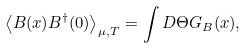Convert formula to latex. <formula><loc_0><loc_0><loc_500><loc_500>\left \langle B ( x ) B ^ { \dagger } ( 0 ) \right \rangle _ { \mu , T } = \int D \Theta G _ { B } ( x ) ,</formula> 